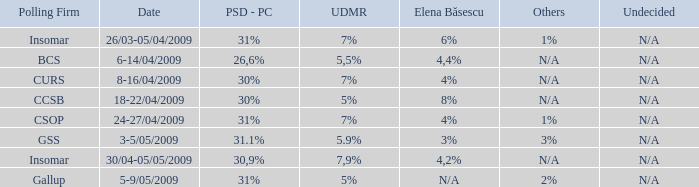What date has the others of 2%? 5-9/05/2009. 